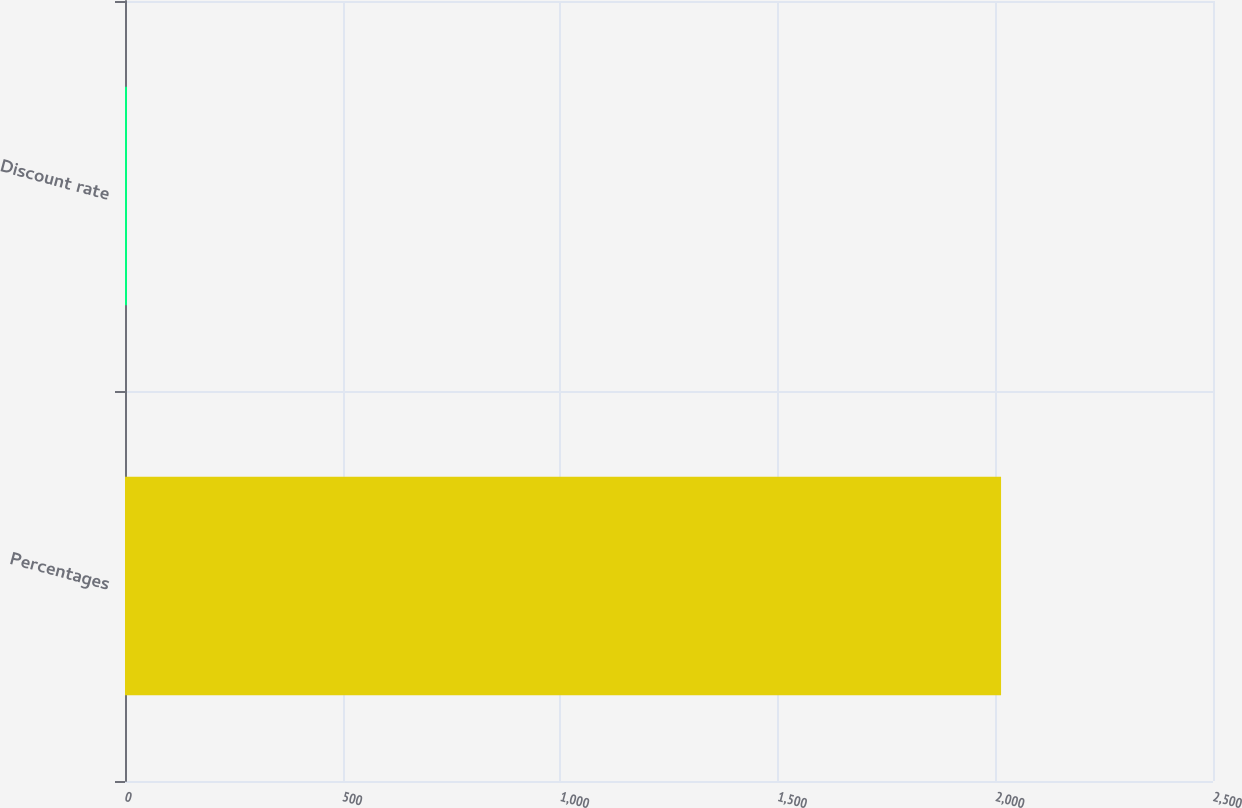Convert chart to OTSL. <chart><loc_0><loc_0><loc_500><loc_500><bar_chart><fcel>Percentages<fcel>Discount rate<nl><fcel>2013<fcel>4.47<nl></chart> 